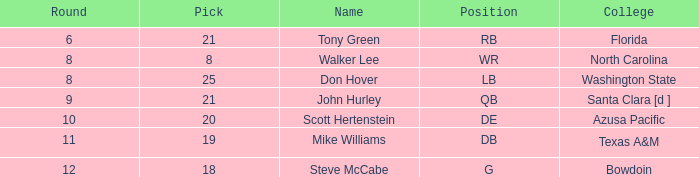What college has an overall less than 243, and tony green as the name? Florida. 